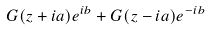<formula> <loc_0><loc_0><loc_500><loc_500>G ( z + i a ) e ^ { i b } + G ( z - i a ) e ^ { - i b }</formula> 